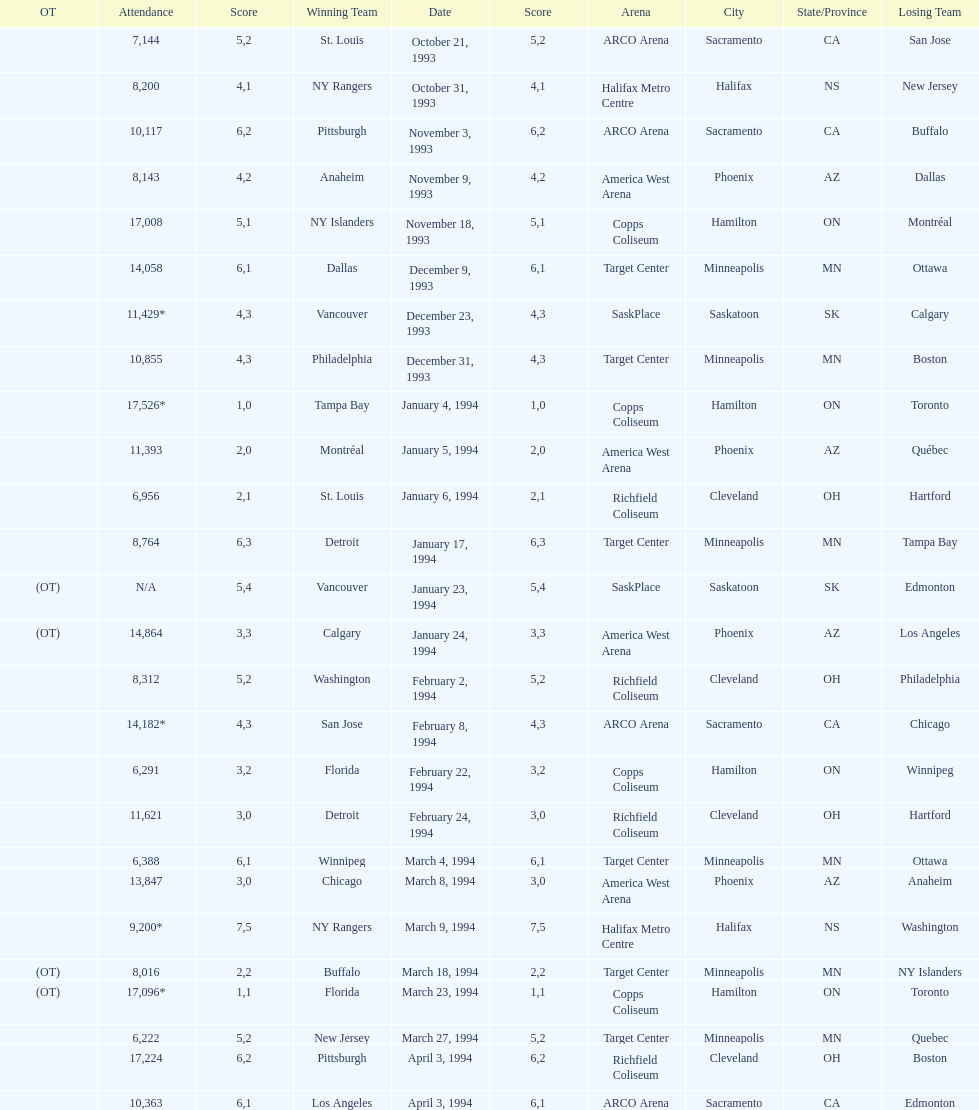Between january 24, 1994, and december 23, 1993, which event had a larger number of attendees? January 4, 1994. Write the full table. {'header': ['OT', 'Attendance', 'Score', 'Winning Team', 'Date', 'Score', 'Arena', 'City', 'State/Province', 'Losing Team'], 'rows': [['', '7,144', '5', 'St. Louis', 'October 21, 1993', '2', 'ARCO Arena', 'Sacramento', 'CA', 'San Jose'], ['', '8,200', '4', 'NY Rangers', 'October 31, 1993', '1', 'Halifax Metro Centre', 'Halifax', 'NS', 'New Jersey'], ['', '10,117', '6', 'Pittsburgh', 'November 3, 1993', '2', 'ARCO Arena', 'Sacramento', 'CA', 'Buffalo'], ['', '8,143', '4', 'Anaheim', 'November 9, 1993', '2', 'America West Arena', 'Phoenix', 'AZ', 'Dallas'], ['', '17,008', '5', 'NY Islanders', 'November 18, 1993', '1', 'Copps Coliseum', 'Hamilton', 'ON', 'Montréal'], ['', '14,058', '6', 'Dallas', 'December 9, 1993', '1', 'Target Center', 'Minneapolis', 'MN', 'Ottawa'], ['', '11,429*', '4', 'Vancouver', 'December 23, 1993', '3', 'SaskPlace', 'Saskatoon', 'SK', 'Calgary'], ['', '10,855', '4', 'Philadelphia', 'December 31, 1993', '3', 'Target Center', 'Minneapolis', 'MN', 'Boston'], ['', '17,526*', '1', 'Tampa Bay', 'January 4, 1994', '0', 'Copps Coliseum', 'Hamilton', 'ON', 'Toronto'], ['', '11,393', '2', 'Montréal', 'January 5, 1994', '0', 'America West Arena', 'Phoenix', 'AZ', 'Québec'], ['', '6,956', '2', 'St. Louis', 'January 6, 1994', '1', 'Richfield Coliseum', 'Cleveland', 'OH', 'Hartford'], ['', '8,764', '6', 'Detroit', 'January 17, 1994', '3', 'Target Center', 'Minneapolis', 'MN', 'Tampa Bay'], ['(OT)', 'N/A', '5', 'Vancouver', 'January 23, 1994', '4', 'SaskPlace', 'Saskatoon', 'SK', 'Edmonton'], ['(OT)', '14,864', '3', 'Calgary', 'January 24, 1994', '3', 'America West Arena', 'Phoenix', 'AZ', 'Los Angeles'], ['', '8,312', '5', 'Washington', 'February 2, 1994', '2', 'Richfield Coliseum', 'Cleveland', 'OH', 'Philadelphia'], ['', '14,182*', '4', 'San Jose', 'February 8, 1994', '3', 'ARCO Arena', 'Sacramento', 'CA', 'Chicago'], ['', '6,291', '3', 'Florida', 'February 22, 1994', '2', 'Copps Coliseum', 'Hamilton', 'ON', 'Winnipeg'], ['', '11,621', '3', 'Detroit', 'February 24, 1994', '0', 'Richfield Coliseum', 'Cleveland', 'OH', 'Hartford'], ['', '6,388', '6', 'Winnipeg', 'March 4, 1994', '1', 'Target Center', 'Minneapolis', 'MN', 'Ottawa'], ['', '13,847', '3', 'Chicago', 'March 8, 1994', '0', 'America West Arena', 'Phoenix', 'AZ', 'Anaheim'], ['', '9,200*', '7', 'NY Rangers', 'March 9, 1994', '5', 'Halifax Metro Centre', 'Halifax', 'NS', 'Washington'], ['(OT)', '8,016', '2', 'Buffalo', 'March 18, 1994', '2', 'Target Center', 'Minneapolis', 'MN', 'NY Islanders'], ['(OT)', '17,096*', '1', 'Florida', 'March 23, 1994', '1', 'Copps Coliseum', 'Hamilton', 'ON', 'Toronto'], ['', '6,222', '5', 'New Jersey', 'March 27, 1994', '2', 'Target Center', 'Minneapolis', 'MN', 'Quebec'], ['', '17,224', '6', 'Pittsburgh', 'April 3, 1994', '2', 'Richfield Coliseum', 'Cleveland', 'OH', 'Boston'], ['', '10,363', '6', 'Los Angeles', 'April 3, 1994', '1', 'ARCO Arena', 'Sacramento', 'CA', 'Edmonton']]} 